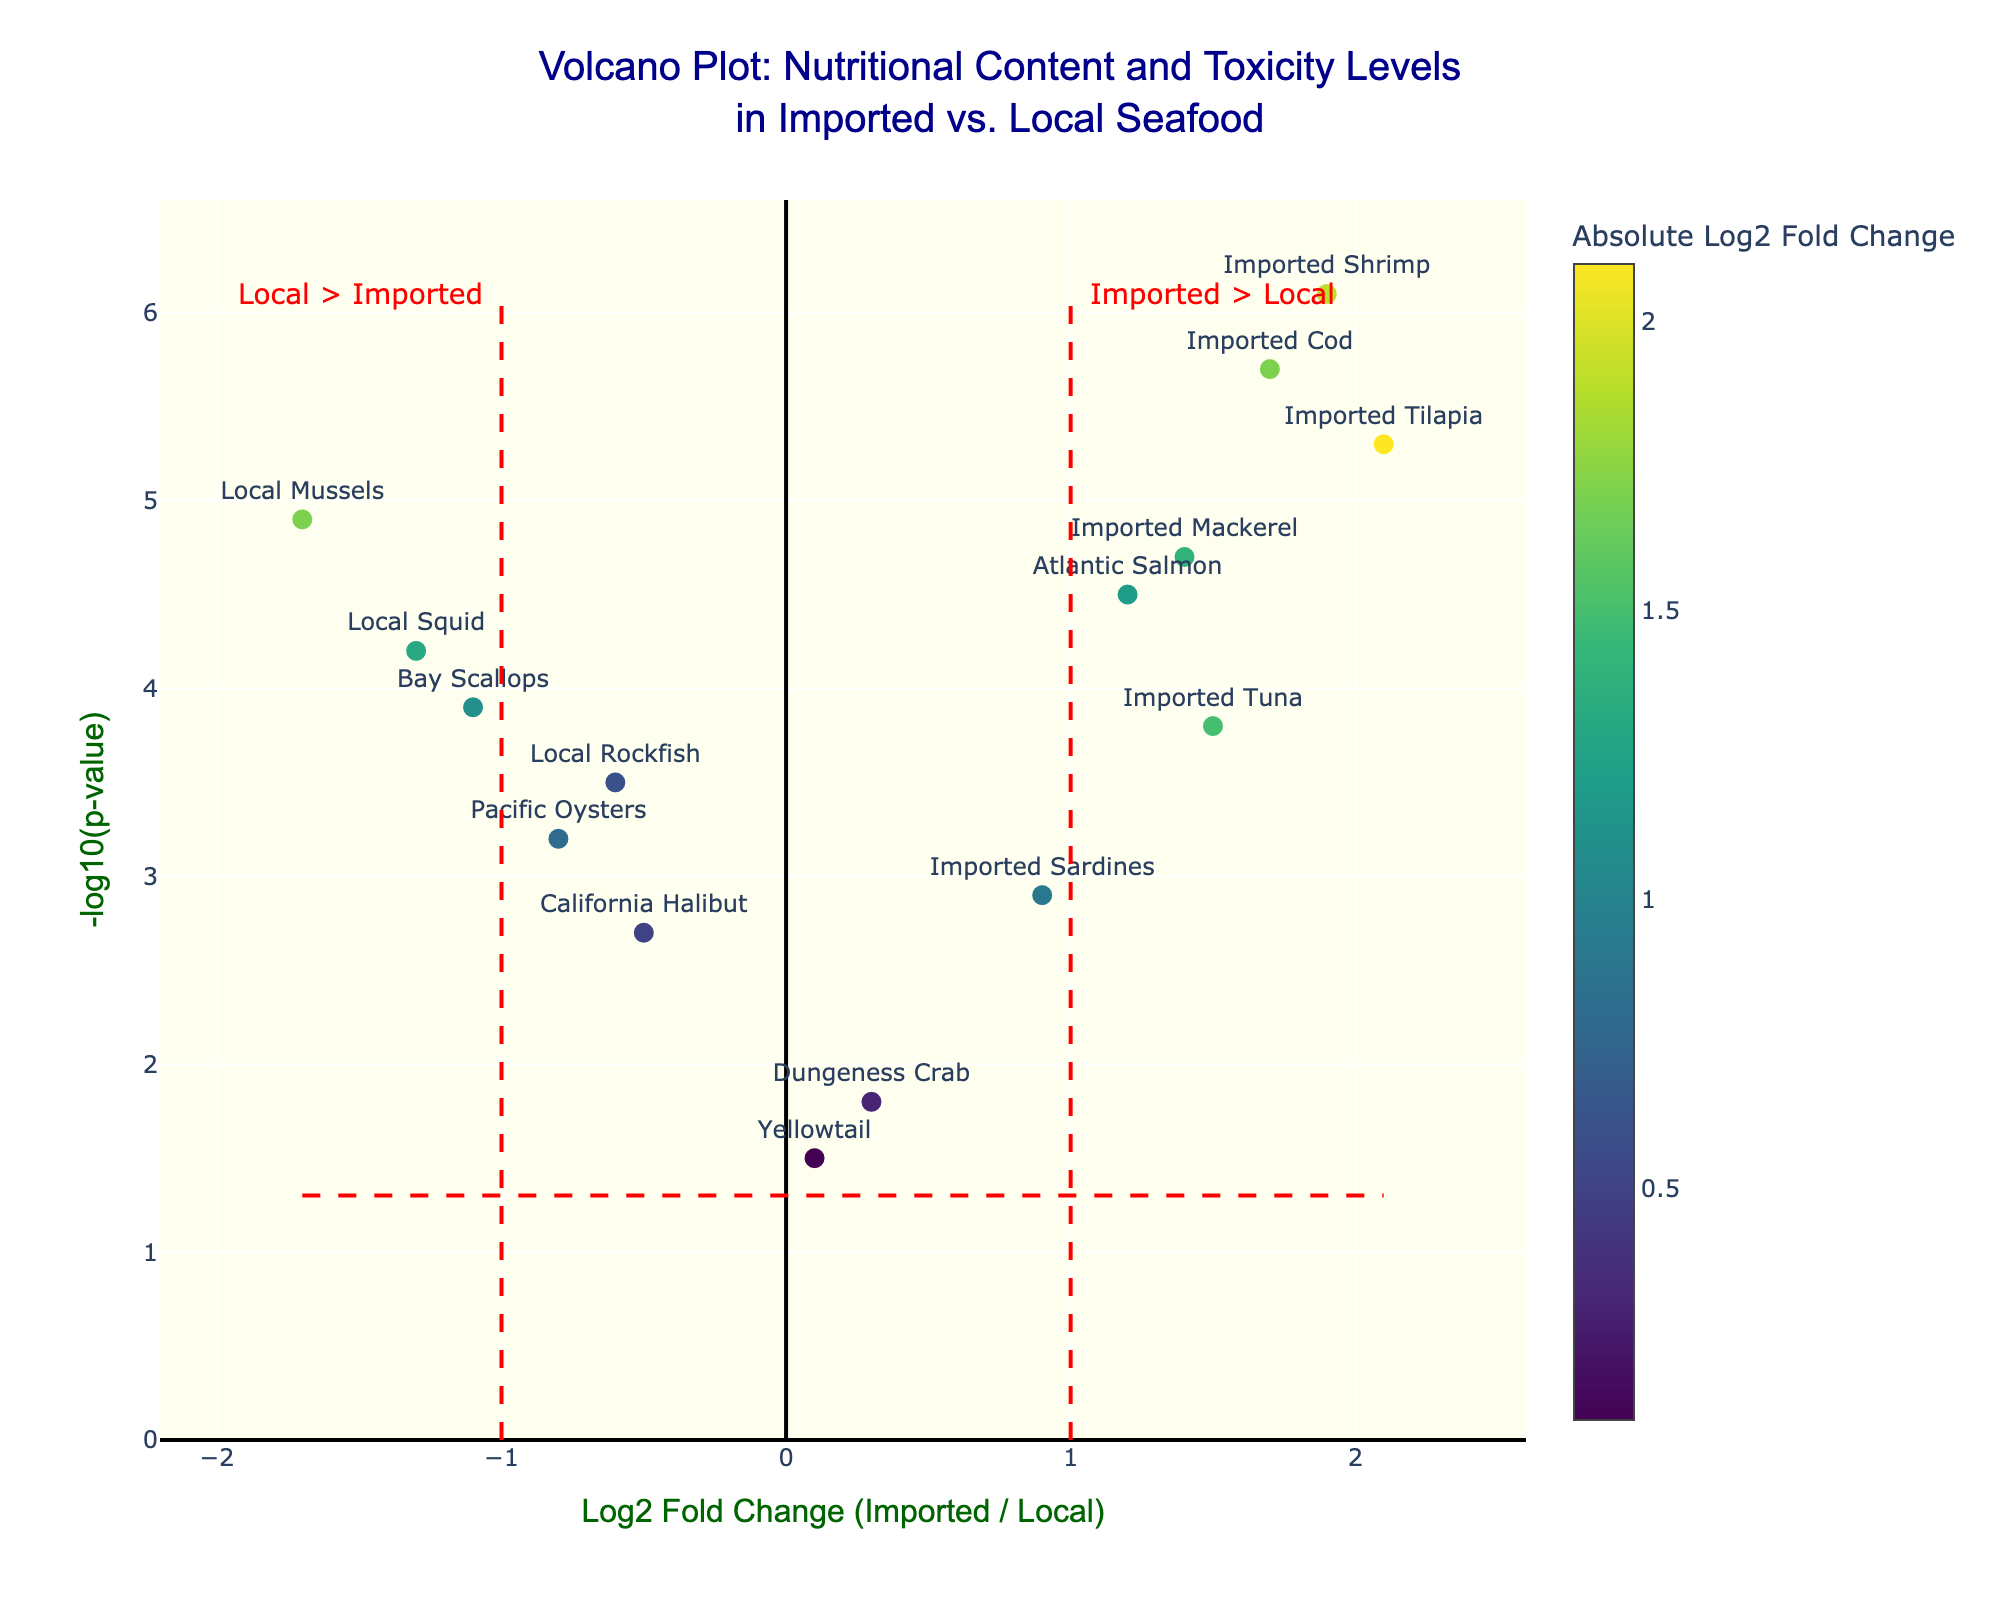What is the Log2 Fold Change for Imported Tilapia? Look at the horizontal axis and locate the value corresponding to Imported Tilapia. According to the data, Imported Tilapia has a Log2 Fold Change of 2.1.
Answer: 2.1 Which ingredient has the highest -log10(p-value)? Examine the vertical axis to find the ingredient with the highest y-coordinate. Imported Shrimp has the highest -log10(p-value) of 6.1.
Answer: Imported Shrimp How many ingredients exhibit higher nutritional content and toxicity in imported forms compared to local forms? Identify ingredients with a positive Log2 Fold Change and a -log10(p-value) greater than 1.30. These include: Atlantic Salmon, Imported Tilapia, Imported Shrimp, Imported Tuna, Imported Cod, Imported Mackerel, and Imported Sardines.
Answer: 7 Which ingredient has the lowest Log2 Fold Change among those with significant values (-log10(p-value) > 1.30)? Locate the ingredient with the lowest Log2 Fold Change on the figure. Local Mussels, with a Log2 Fold Change of -1.7, fits this criterion.
Answer: Local Mussels Compare the toxicity levels of Local Mussels and Imported Tilapia. Which has a higher toxicity level? Find their respective -log10(p-value) values. Both ingredients have significant values, but Imported Tilapia's -log10(p-value) is 5.3, while Local Mussels’ is 4.9. So, Imported Tilapia has higher toxicity.
Answer: Imported Tilapia How many ingredients have a Log2 Fold Change less than -1? Count the ingredients that fall to the left of the vertical line at -1. These include Local Mussels and Local Squid.
Answer: 2 What does a positive Log2 Fold Change indicate in this context? A positive Log2 Fold Change indicates that the nutritional content and toxicity levels are higher in imported seafood ingredients compared to local seafood ingredients.
Answer: Higher in imported ingredients Compare the toxicity levels of Pacific Oysters and California Halibut. Are they significantly different? Look at the -log10(p-value) for both. Pacific Oysters have 3.2, and California Halibut has 2.7. Both values exceed the significance threshold of 1.30, but their difference isn't substantial in terms of interpretation.
Answer: Not significantly different 